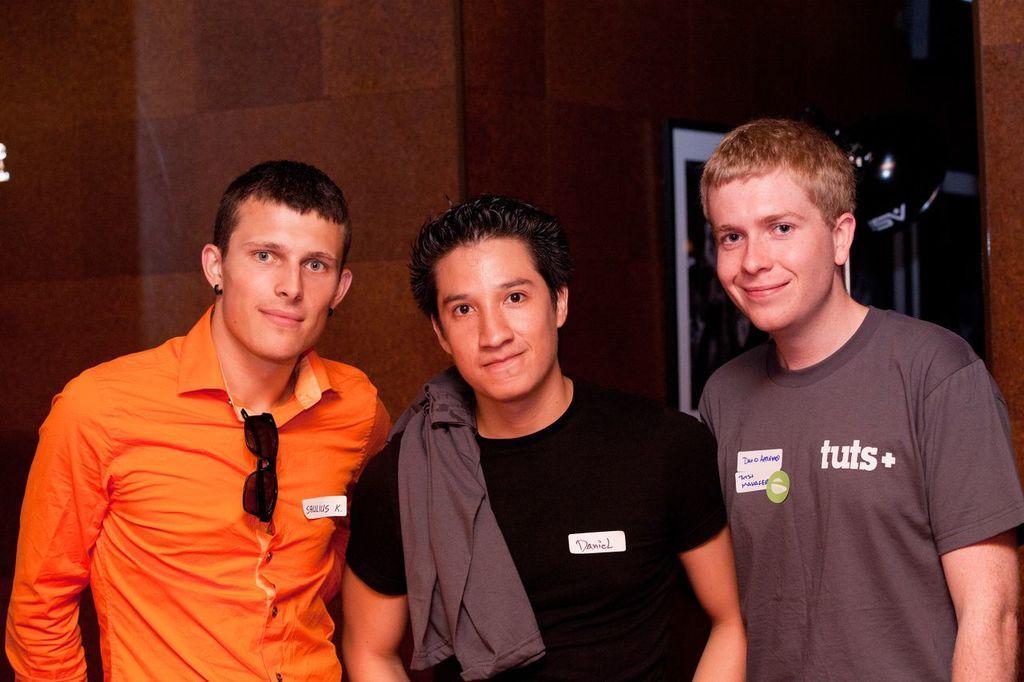In one or two sentences, can you explain what this image depicts? In the center of the image there are people. In the background of the image there is wall. There is photo frame. 